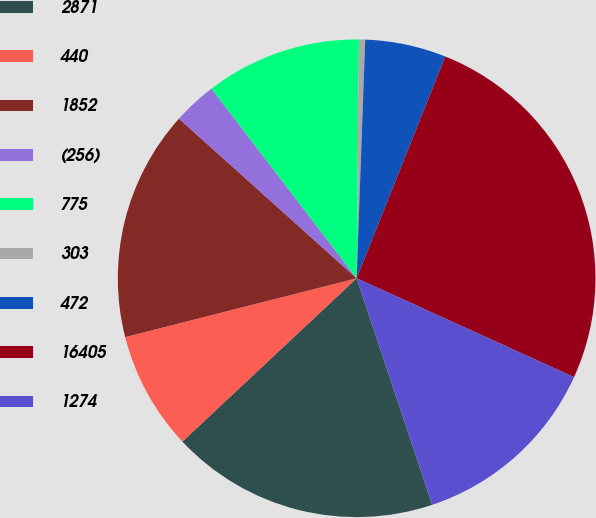<chart> <loc_0><loc_0><loc_500><loc_500><pie_chart><fcel>2871<fcel>440<fcel>1852<fcel>(256)<fcel>775<fcel>303<fcel>472<fcel>16405<fcel>1274<nl><fcel>18.14%<fcel>8.02%<fcel>15.61%<fcel>2.95%<fcel>10.55%<fcel>0.42%<fcel>5.48%<fcel>25.74%<fcel>13.08%<nl></chart> 